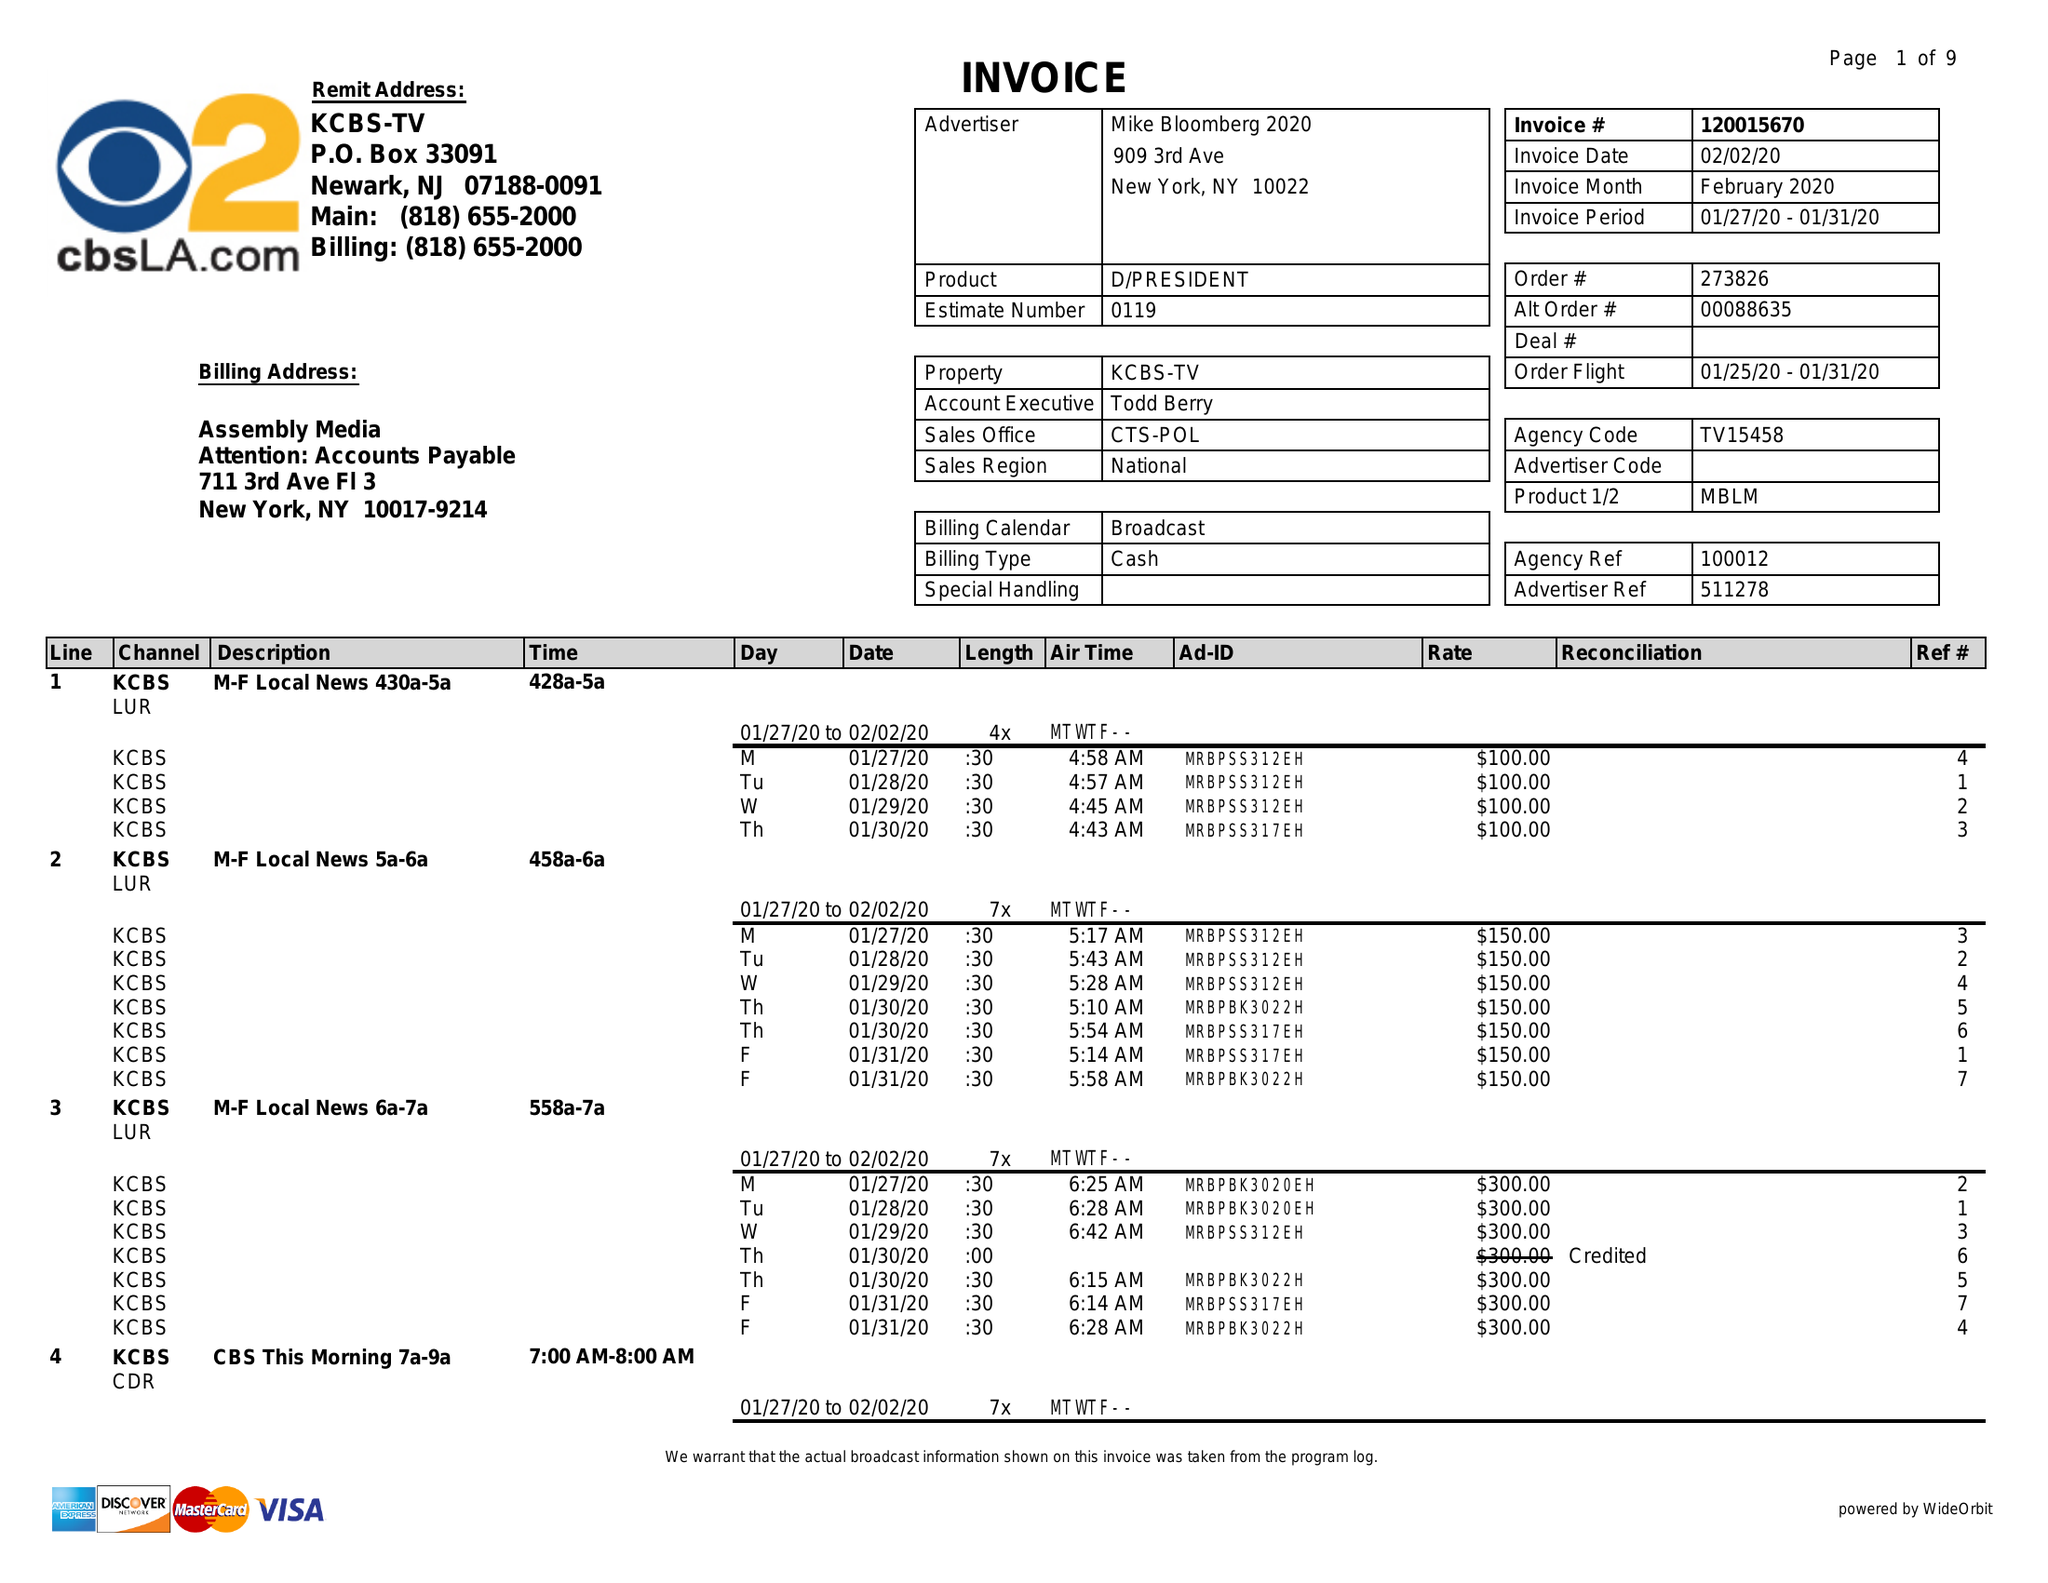What is the value for the gross_amount?
Answer the question using a single word or phrase. 182210.00 